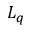<formula> <loc_0><loc_0><loc_500><loc_500>L _ { q }</formula> 